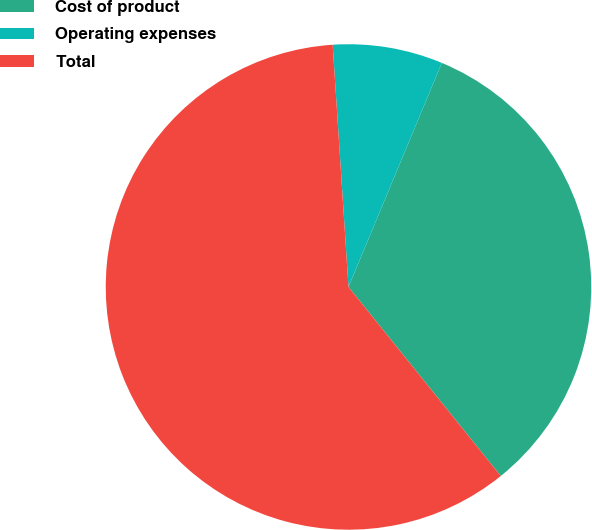Convert chart to OTSL. <chart><loc_0><loc_0><loc_500><loc_500><pie_chart><fcel>Cost of product<fcel>Operating expenses<fcel>Total<nl><fcel>32.93%<fcel>7.32%<fcel>59.76%<nl></chart> 